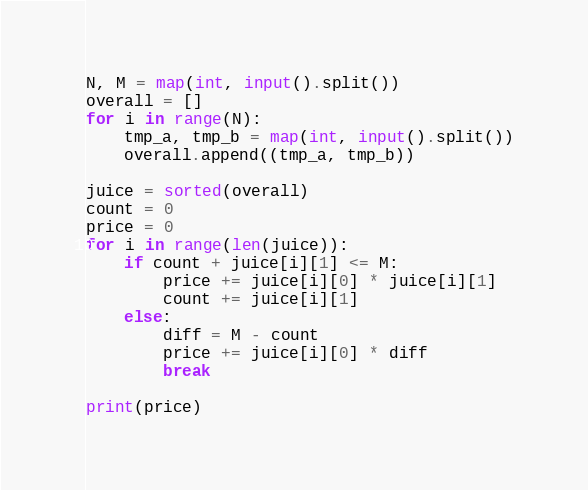<code> <loc_0><loc_0><loc_500><loc_500><_Python_>N, M = map(int, input().split())
overall = []
for i in range(N):
    tmp_a, tmp_b = map(int, input().split())
    overall.append((tmp_a, tmp_b))

juice = sorted(overall)
count = 0
price = 0
for i in range(len(juice)):
    if count + juice[i][1] <= M:
        price += juice[i][0] * juice[i][1]
        count += juice[i][1]
    else:
        diff = M - count
        price += juice[i][0] * diff
        break
        
print(price)</code> 